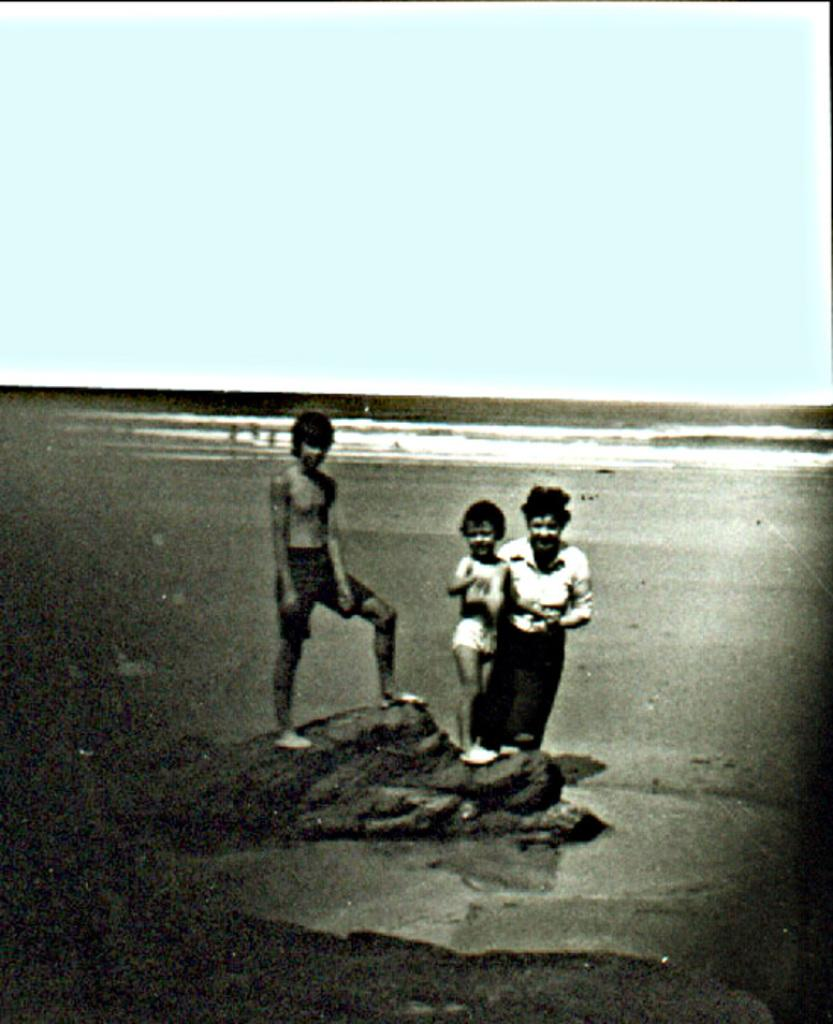What is: What is the color scheme of the image? The image is black and white. What is the boy in the image doing? The boy is standing on a rock in the middle of the image. Who else is present in the image besides the boy? Two persons are smiling on the right side of the image. What can be seen at the top of the image? The sky is visible at the top of the image. What type of tramp is visible in the image? There is no tramp present in the image. How many needles are being used by the boy in the image? There are no needles visible in the image; the boy is standing on a rock. What kind of cover is protecting the persons in the image? There is no cover present in the image; the persons are exposed to the elements. 